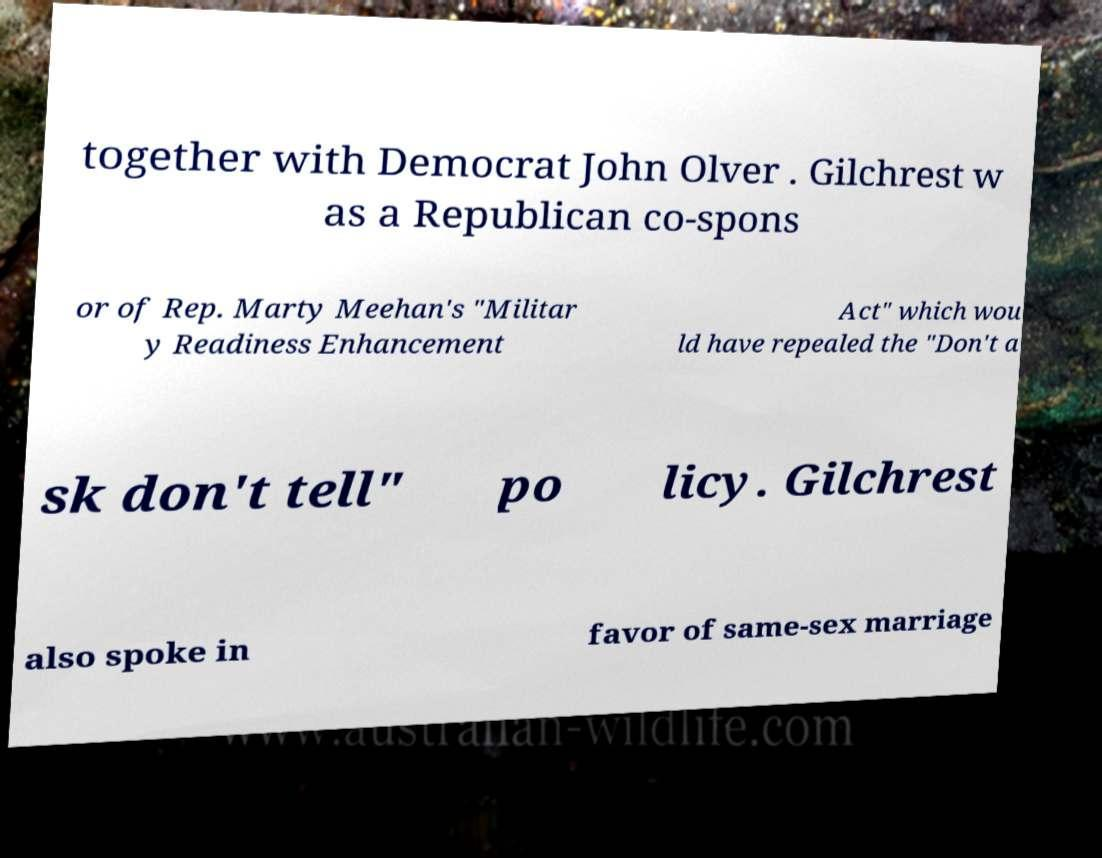I need the written content from this picture converted into text. Can you do that? together with Democrat John Olver . Gilchrest w as a Republican co-spons or of Rep. Marty Meehan's "Militar y Readiness Enhancement Act" which wou ld have repealed the "Don't a sk don't tell" po licy. Gilchrest also spoke in favor of same-sex marriage 